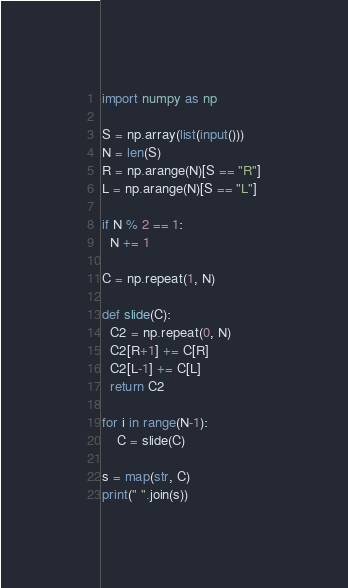<code> <loc_0><loc_0><loc_500><loc_500><_Python_>import numpy as np

S = np.array(list(input()))
N = len(S)
R = np.arange(N)[S == "R"]
L = np.arange(N)[S == "L"]

if N % 2 == 1:
  N += 1
 
C = np.repeat(1, N)
 
def slide(C):
  C2 = np.repeat(0, N)
  C2[R+1] += C[R]
  C2[L-1] += C[L]
  return C2
 
for i in range(N-1):
	C = slide(C)
 
s = map(str, C)
print(" ".join(s))</code> 